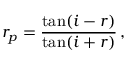Convert formula to latex. <formula><loc_0><loc_0><loc_500><loc_500>r _ { p } = { \frac { \tan ( i - r ) } { \tan ( i + r ) } } \, ,</formula> 